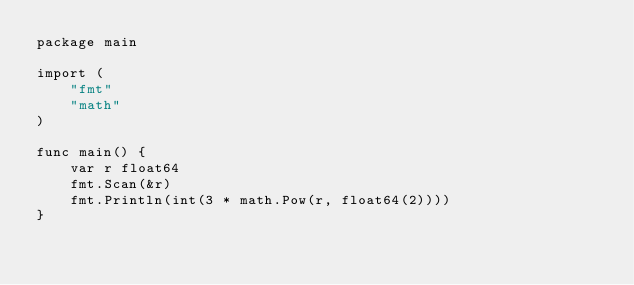<code> <loc_0><loc_0><loc_500><loc_500><_Go_>package main

import (
	"fmt"
	"math"
)

func main() {
	var r float64
	fmt.Scan(&r)
	fmt.Println(int(3 * math.Pow(r, float64(2))))
}
</code> 